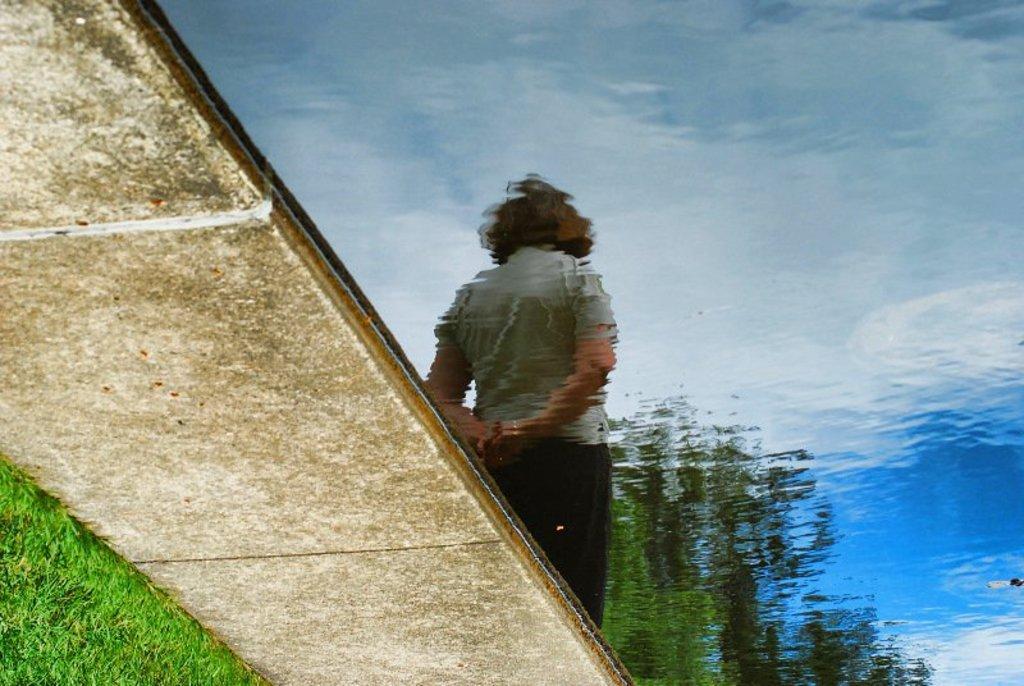Can you describe this image briefly? On the left side of the image there is a floor. In the bottom left corner of the image there is grass. And on the right side of the image there is water. On the water there is a reflection of a person. 